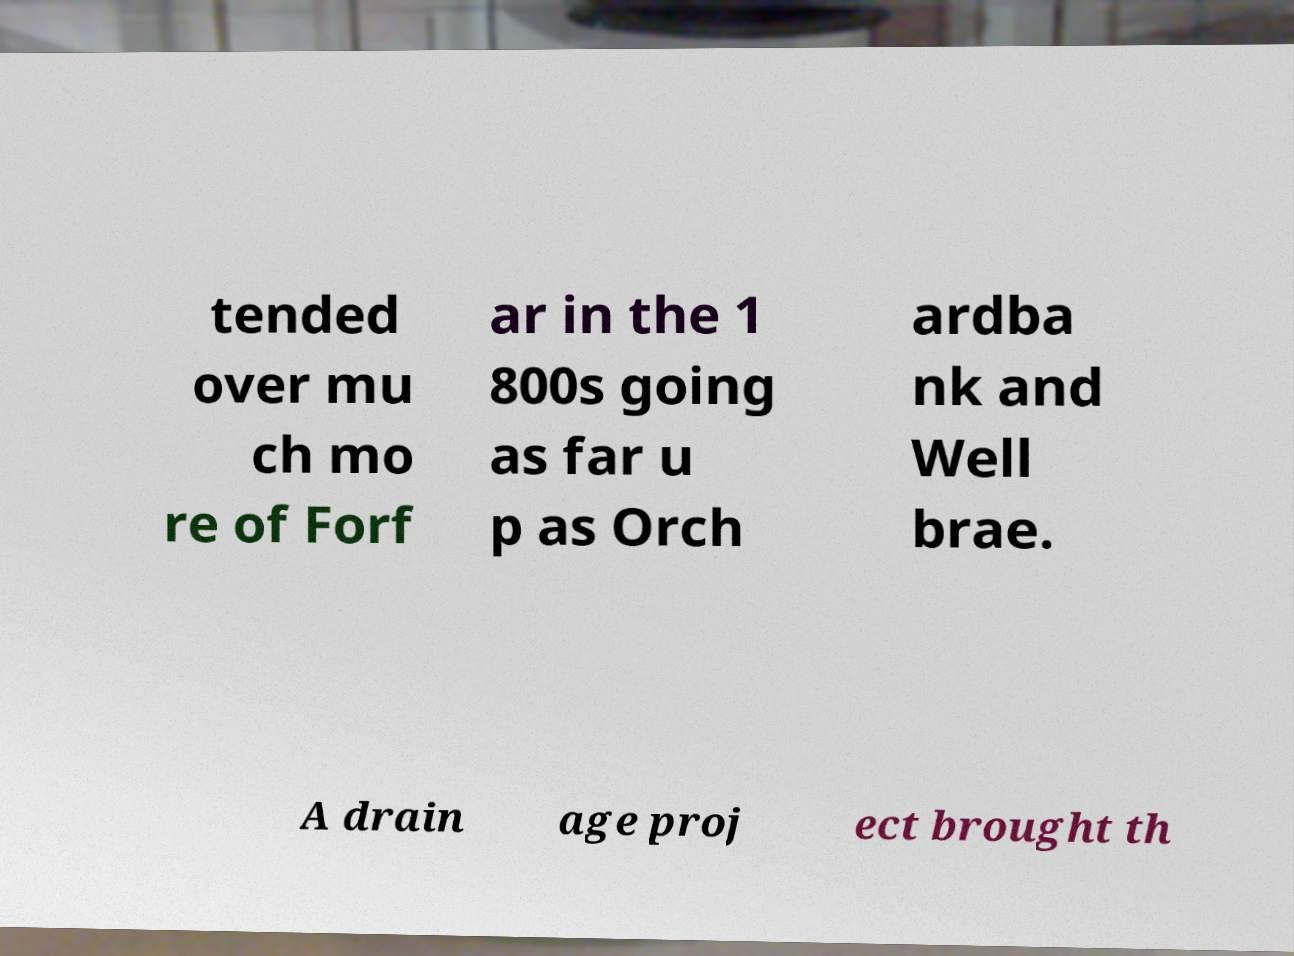I need the written content from this picture converted into text. Can you do that? tended over mu ch mo re of Forf ar in the 1 800s going as far u p as Orch ardba nk and Well brae. A drain age proj ect brought th 